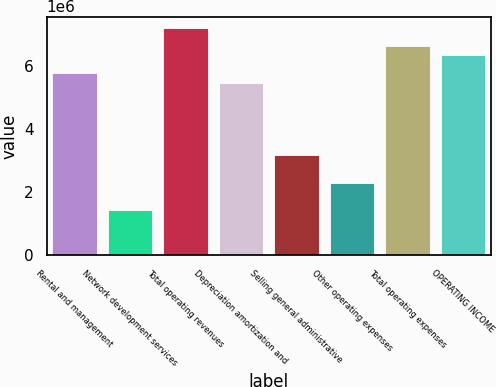Convert chart to OTSL. <chart><loc_0><loc_0><loc_500><loc_500><bar_chart><fcel>Rental and management<fcel>Network development services<fcel>Total operating revenues<fcel>Depreciation amortization and<fcel>Selling general administrative<fcel>Other operating expenses<fcel>Total operating expenses<fcel>OPERATING INCOME<nl><fcel>5.75192e+06<fcel>1.43798e+06<fcel>7.1899e+06<fcel>5.46432e+06<fcel>3.16356e+06<fcel>2.30077e+06<fcel>6.61471e+06<fcel>6.32711e+06<nl></chart> 